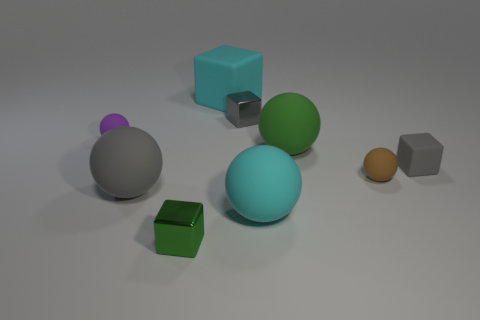Subtract all gray spheres. How many spheres are left? 4 Subtract 1 cubes. How many cubes are left? 3 Subtract all gray rubber balls. How many balls are left? 4 Subtract all blue balls. Subtract all yellow cylinders. How many balls are left? 5 Add 1 small red matte cubes. How many objects exist? 10 Subtract all blocks. How many objects are left? 5 Add 1 small rubber blocks. How many small rubber blocks exist? 2 Subtract 0 yellow cylinders. How many objects are left? 9 Subtract all green matte objects. Subtract all large cyan rubber blocks. How many objects are left? 7 Add 4 gray rubber blocks. How many gray rubber blocks are left? 5 